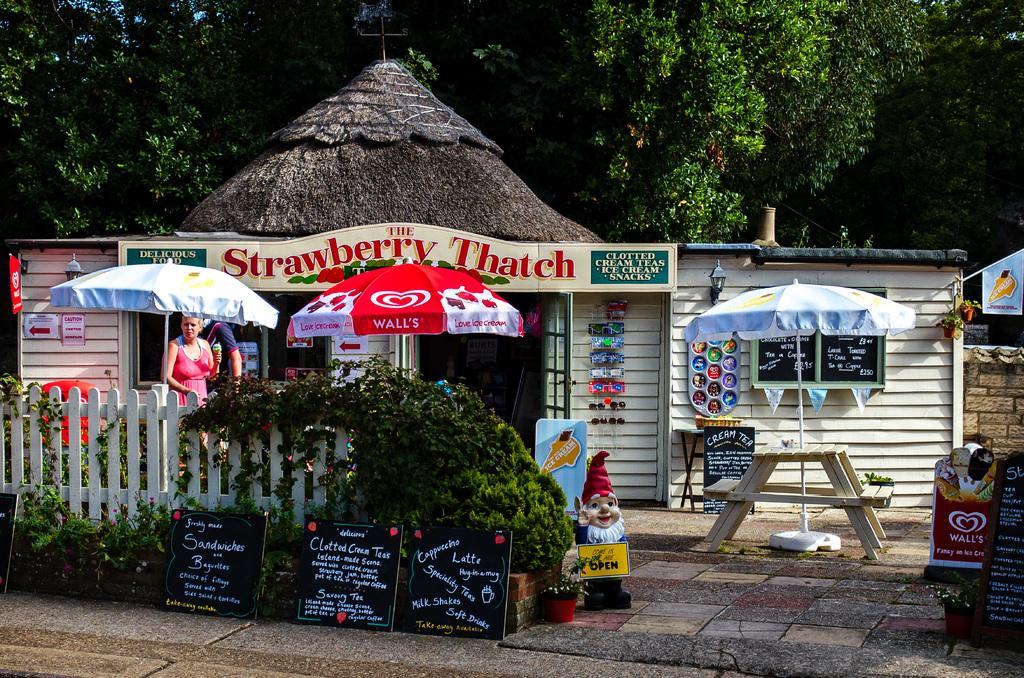In one or two sentences, can you explain what this image depicts? There is a a cafe and outside the cafe there are three umbrellas and below the umbrellas there are tables to sit and there is a white fencing around the cafe and beside that there are few plants and in front of the fence there are three black boards and there are some menu items are written on the blackboards,in the background there are plenty of trees. 